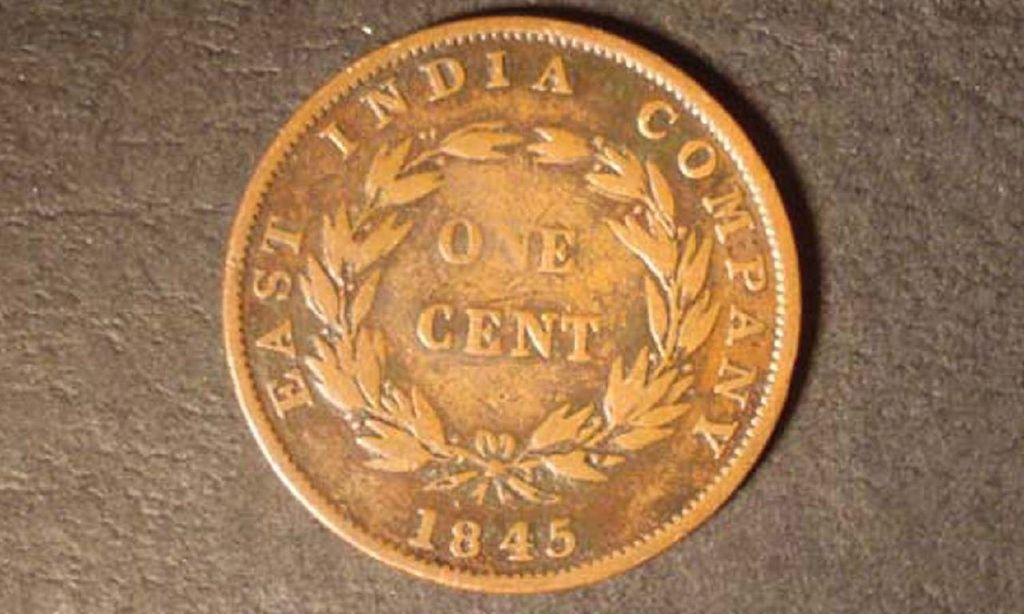Provide a one-sentence caption for the provided image. A once cent East India Company coin from 1845 sits on a countertop. 